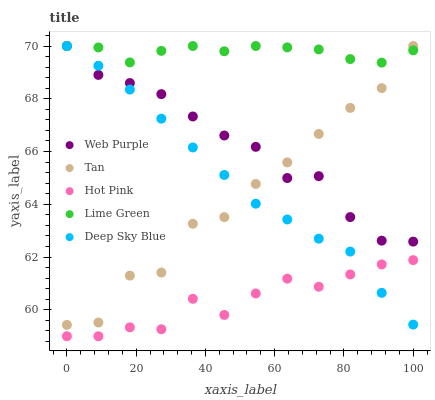Does Hot Pink have the minimum area under the curve?
Answer yes or no. Yes. Does Lime Green have the maximum area under the curve?
Answer yes or no. Yes. Does Lime Green have the minimum area under the curve?
Answer yes or no. No. Does Hot Pink have the maximum area under the curve?
Answer yes or no. No. Is Deep Sky Blue the smoothest?
Answer yes or no. Yes. Is Tan the roughest?
Answer yes or no. Yes. Is Hot Pink the smoothest?
Answer yes or no. No. Is Hot Pink the roughest?
Answer yes or no. No. Does Hot Pink have the lowest value?
Answer yes or no. Yes. Does Lime Green have the lowest value?
Answer yes or no. No. Does Deep Sky Blue have the highest value?
Answer yes or no. Yes. Does Hot Pink have the highest value?
Answer yes or no. No. Is Hot Pink less than Tan?
Answer yes or no. Yes. Is Tan greater than Hot Pink?
Answer yes or no. Yes. Does Lime Green intersect Tan?
Answer yes or no. Yes. Is Lime Green less than Tan?
Answer yes or no. No. Is Lime Green greater than Tan?
Answer yes or no. No. Does Hot Pink intersect Tan?
Answer yes or no. No. 